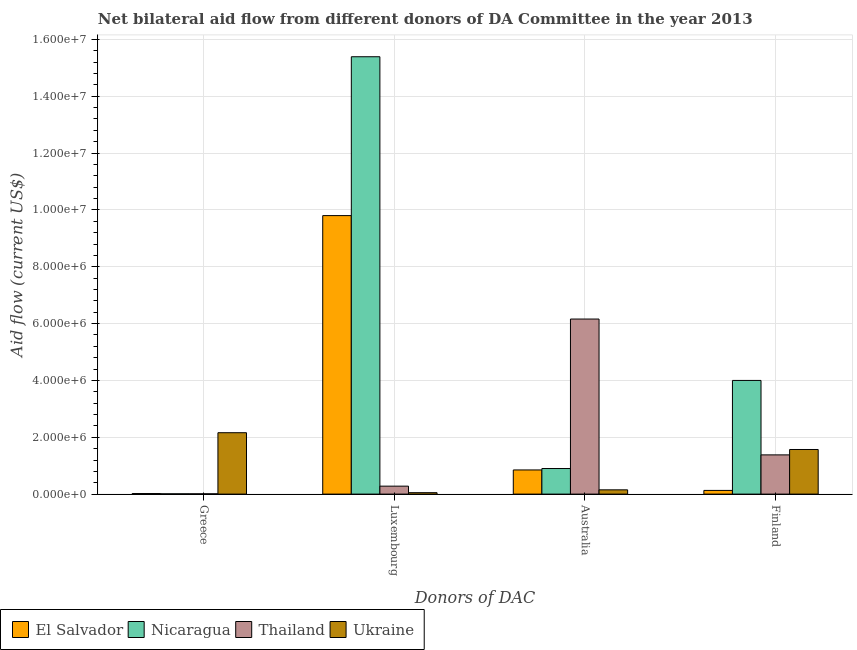How many groups of bars are there?
Your answer should be very brief. 4. How many bars are there on the 2nd tick from the left?
Ensure brevity in your answer.  4. What is the amount of aid given by finland in Thailand?
Offer a terse response. 1.38e+06. Across all countries, what is the maximum amount of aid given by greece?
Provide a succinct answer. 2.16e+06. Across all countries, what is the minimum amount of aid given by finland?
Keep it short and to the point. 1.30e+05. In which country was the amount of aid given by australia maximum?
Your answer should be compact. Thailand. In which country was the amount of aid given by australia minimum?
Ensure brevity in your answer.  Ukraine. What is the total amount of aid given by finland in the graph?
Provide a succinct answer. 7.08e+06. What is the difference between the amount of aid given by luxembourg in Thailand and that in Nicaragua?
Provide a short and direct response. -1.51e+07. What is the difference between the amount of aid given by luxembourg in Thailand and the amount of aid given by greece in El Salvador?
Offer a terse response. 2.60e+05. What is the average amount of aid given by finland per country?
Your answer should be compact. 1.77e+06. What is the difference between the amount of aid given by finland and amount of aid given by luxembourg in Nicaragua?
Offer a very short reply. -1.14e+07. What is the ratio of the amount of aid given by luxembourg in Nicaragua to that in Ukraine?
Offer a very short reply. 307.8. Is the difference between the amount of aid given by greece in Nicaragua and Thailand greater than the difference between the amount of aid given by luxembourg in Nicaragua and Thailand?
Offer a terse response. No. What is the difference between the highest and the second highest amount of aid given by greece?
Provide a short and direct response. 2.14e+06. What is the difference between the highest and the lowest amount of aid given by greece?
Your answer should be very brief. 2.15e+06. In how many countries, is the amount of aid given by australia greater than the average amount of aid given by australia taken over all countries?
Offer a terse response. 1. Is it the case that in every country, the sum of the amount of aid given by greece and amount of aid given by luxembourg is greater than the sum of amount of aid given by finland and amount of aid given by australia?
Offer a terse response. No. What does the 4th bar from the left in Greece represents?
Your response must be concise. Ukraine. What does the 3rd bar from the right in Luxembourg represents?
Offer a terse response. Nicaragua. Is it the case that in every country, the sum of the amount of aid given by greece and amount of aid given by luxembourg is greater than the amount of aid given by australia?
Ensure brevity in your answer.  No. How many bars are there?
Make the answer very short. 16. Are all the bars in the graph horizontal?
Ensure brevity in your answer.  No. What is the difference between two consecutive major ticks on the Y-axis?
Keep it short and to the point. 2.00e+06. Are the values on the major ticks of Y-axis written in scientific E-notation?
Ensure brevity in your answer.  Yes. Does the graph contain any zero values?
Make the answer very short. No. Does the graph contain grids?
Ensure brevity in your answer.  Yes. How many legend labels are there?
Your response must be concise. 4. What is the title of the graph?
Ensure brevity in your answer.  Net bilateral aid flow from different donors of DA Committee in the year 2013. What is the label or title of the X-axis?
Offer a very short reply. Donors of DAC. What is the Aid flow (current US$) of El Salvador in Greece?
Your response must be concise. 2.00e+04. What is the Aid flow (current US$) in Nicaragua in Greece?
Provide a short and direct response. 10000. What is the Aid flow (current US$) in Thailand in Greece?
Give a very brief answer. 10000. What is the Aid flow (current US$) in Ukraine in Greece?
Provide a succinct answer. 2.16e+06. What is the Aid flow (current US$) in El Salvador in Luxembourg?
Offer a very short reply. 9.80e+06. What is the Aid flow (current US$) of Nicaragua in Luxembourg?
Give a very brief answer. 1.54e+07. What is the Aid flow (current US$) of Thailand in Luxembourg?
Offer a terse response. 2.80e+05. What is the Aid flow (current US$) in El Salvador in Australia?
Your response must be concise. 8.50e+05. What is the Aid flow (current US$) of Nicaragua in Australia?
Give a very brief answer. 9.00e+05. What is the Aid flow (current US$) of Thailand in Australia?
Ensure brevity in your answer.  6.16e+06. What is the Aid flow (current US$) in Ukraine in Australia?
Make the answer very short. 1.50e+05. What is the Aid flow (current US$) in Thailand in Finland?
Your answer should be compact. 1.38e+06. What is the Aid flow (current US$) of Ukraine in Finland?
Offer a very short reply. 1.57e+06. Across all Donors of DAC, what is the maximum Aid flow (current US$) in El Salvador?
Your answer should be compact. 9.80e+06. Across all Donors of DAC, what is the maximum Aid flow (current US$) of Nicaragua?
Ensure brevity in your answer.  1.54e+07. Across all Donors of DAC, what is the maximum Aid flow (current US$) of Thailand?
Keep it short and to the point. 6.16e+06. Across all Donors of DAC, what is the maximum Aid flow (current US$) in Ukraine?
Ensure brevity in your answer.  2.16e+06. Across all Donors of DAC, what is the minimum Aid flow (current US$) in Nicaragua?
Offer a very short reply. 10000. Across all Donors of DAC, what is the minimum Aid flow (current US$) of Ukraine?
Your answer should be very brief. 5.00e+04. What is the total Aid flow (current US$) in El Salvador in the graph?
Ensure brevity in your answer.  1.08e+07. What is the total Aid flow (current US$) in Nicaragua in the graph?
Your answer should be compact. 2.03e+07. What is the total Aid flow (current US$) of Thailand in the graph?
Offer a very short reply. 7.83e+06. What is the total Aid flow (current US$) of Ukraine in the graph?
Offer a terse response. 3.93e+06. What is the difference between the Aid flow (current US$) of El Salvador in Greece and that in Luxembourg?
Your response must be concise. -9.78e+06. What is the difference between the Aid flow (current US$) of Nicaragua in Greece and that in Luxembourg?
Provide a short and direct response. -1.54e+07. What is the difference between the Aid flow (current US$) of Ukraine in Greece and that in Luxembourg?
Give a very brief answer. 2.11e+06. What is the difference between the Aid flow (current US$) in El Salvador in Greece and that in Australia?
Make the answer very short. -8.30e+05. What is the difference between the Aid flow (current US$) in Nicaragua in Greece and that in Australia?
Offer a terse response. -8.90e+05. What is the difference between the Aid flow (current US$) of Thailand in Greece and that in Australia?
Give a very brief answer. -6.15e+06. What is the difference between the Aid flow (current US$) in Ukraine in Greece and that in Australia?
Give a very brief answer. 2.01e+06. What is the difference between the Aid flow (current US$) in Nicaragua in Greece and that in Finland?
Provide a short and direct response. -3.99e+06. What is the difference between the Aid flow (current US$) of Thailand in Greece and that in Finland?
Give a very brief answer. -1.37e+06. What is the difference between the Aid flow (current US$) of Ukraine in Greece and that in Finland?
Keep it short and to the point. 5.90e+05. What is the difference between the Aid flow (current US$) in El Salvador in Luxembourg and that in Australia?
Give a very brief answer. 8.95e+06. What is the difference between the Aid flow (current US$) in Nicaragua in Luxembourg and that in Australia?
Offer a very short reply. 1.45e+07. What is the difference between the Aid flow (current US$) in Thailand in Luxembourg and that in Australia?
Your response must be concise. -5.88e+06. What is the difference between the Aid flow (current US$) in Ukraine in Luxembourg and that in Australia?
Keep it short and to the point. -1.00e+05. What is the difference between the Aid flow (current US$) of El Salvador in Luxembourg and that in Finland?
Keep it short and to the point. 9.67e+06. What is the difference between the Aid flow (current US$) of Nicaragua in Luxembourg and that in Finland?
Ensure brevity in your answer.  1.14e+07. What is the difference between the Aid flow (current US$) of Thailand in Luxembourg and that in Finland?
Your answer should be very brief. -1.10e+06. What is the difference between the Aid flow (current US$) in Ukraine in Luxembourg and that in Finland?
Your answer should be compact. -1.52e+06. What is the difference between the Aid flow (current US$) in El Salvador in Australia and that in Finland?
Your response must be concise. 7.20e+05. What is the difference between the Aid flow (current US$) of Nicaragua in Australia and that in Finland?
Ensure brevity in your answer.  -3.10e+06. What is the difference between the Aid flow (current US$) in Thailand in Australia and that in Finland?
Ensure brevity in your answer.  4.78e+06. What is the difference between the Aid flow (current US$) in Ukraine in Australia and that in Finland?
Offer a terse response. -1.42e+06. What is the difference between the Aid flow (current US$) of El Salvador in Greece and the Aid flow (current US$) of Nicaragua in Luxembourg?
Make the answer very short. -1.54e+07. What is the difference between the Aid flow (current US$) of El Salvador in Greece and the Aid flow (current US$) of Thailand in Luxembourg?
Provide a succinct answer. -2.60e+05. What is the difference between the Aid flow (current US$) of El Salvador in Greece and the Aid flow (current US$) of Ukraine in Luxembourg?
Your response must be concise. -3.00e+04. What is the difference between the Aid flow (current US$) in Nicaragua in Greece and the Aid flow (current US$) in Ukraine in Luxembourg?
Keep it short and to the point. -4.00e+04. What is the difference between the Aid flow (current US$) in Thailand in Greece and the Aid flow (current US$) in Ukraine in Luxembourg?
Ensure brevity in your answer.  -4.00e+04. What is the difference between the Aid flow (current US$) in El Salvador in Greece and the Aid flow (current US$) in Nicaragua in Australia?
Offer a terse response. -8.80e+05. What is the difference between the Aid flow (current US$) of El Salvador in Greece and the Aid flow (current US$) of Thailand in Australia?
Offer a terse response. -6.14e+06. What is the difference between the Aid flow (current US$) of El Salvador in Greece and the Aid flow (current US$) of Ukraine in Australia?
Offer a very short reply. -1.30e+05. What is the difference between the Aid flow (current US$) in Nicaragua in Greece and the Aid flow (current US$) in Thailand in Australia?
Offer a very short reply. -6.15e+06. What is the difference between the Aid flow (current US$) in Nicaragua in Greece and the Aid flow (current US$) in Ukraine in Australia?
Your response must be concise. -1.40e+05. What is the difference between the Aid flow (current US$) of El Salvador in Greece and the Aid flow (current US$) of Nicaragua in Finland?
Your answer should be very brief. -3.98e+06. What is the difference between the Aid flow (current US$) of El Salvador in Greece and the Aid flow (current US$) of Thailand in Finland?
Offer a terse response. -1.36e+06. What is the difference between the Aid flow (current US$) in El Salvador in Greece and the Aid flow (current US$) in Ukraine in Finland?
Keep it short and to the point. -1.55e+06. What is the difference between the Aid flow (current US$) of Nicaragua in Greece and the Aid flow (current US$) of Thailand in Finland?
Give a very brief answer. -1.37e+06. What is the difference between the Aid flow (current US$) of Nicaragua in Greece and the Aid flow (current US$) of Ukraine in Finland?
Offer a terse response. -1.56e+06. What is the difference between the Aid flow (current US$) of Thailand in Greece and the Aid flow (current US$) of Ukraine in Finland?
Provide a succinct answer. -1.56e+06. What is the difference between the Aid flow (current US$) in El Salvador in Luxembourg and the Aid flow (current US$) in Nicaragua in Australia?
Your answer should be very brief. 8.90e+06. What is the difference between the Aid flow (current US$) of El Salvador in Luxembourg and the Aid flow (current US$) of Thailand in Australia?
Your answer should be compact. 3.64e+06. What is the difference between the Aid flow (current US$) in El Salvador in Luxembourg and the Aid flow (current US$) in Ukraine in Australia?
Offer a very short reply. 9.65e+06. What is the difference between the Aid flow (current US$) of Nicaragua in Luxembourg and the Aid flow (current US$) of Thailand in Australia?
Provide a short and direct response. 9.23e+06. What is the difference between the Aid flow (current US$) of Nicaragua in Luxembourg and the Aid flow (current US$) of Ukraine in Australia?
Provide a short and direct response. 1.52e+07. What is the difference between the Aid flow (current US$) of Thailand in Luxembourg and the Aid flow (current US$) of Ukraine in Australia?
Offer a very short reply. 1.30e+05. What is the difference between the Aid flow (current US$) of El Salvador in Luxembourg and the Aid flow (current US$) of Nicaragua in Finland?
Your answer should be very brief. 5.80e+06. What is the difference between the Aid flow (current US$) in El Salvador in Luxembourg and the Aid flow (current US$) in Thailand in Finland?
Make the answer very short. 8.42e+06. What is the difference between the Aid flow (current US$) of El Salvador in Luxembourg and the Aid flow (current US$) of Ukraine in Finland?
Your answer should be very brief. 8.23e+06. What is the difference between the Aid flow (current US$) of Nicaragua in Luxembourg and the Aid flow (current US$) of Thailand in Finland?
Offer a terse response. 1.40e+07. What is the difference between the Aid flow (current US$) of Nicaragua in Luxembourg and the Aid flow (current US$) of Ukraine in Finland?
Give a very brief answer. 1.38e+07. What is the difference between the Aid flow (current US$) in Thailand in Luxembourg and the Aid flow (current US$) in Ukraine in Finland?
Provide a short and direct response. -1.29e+06. What is the difference between the Aid flow (current US$) of El Salvador in Australia and the Aid flow (current US$) of Nicaragua in Finland?
Give a very brief answer. -3.15e+06. What is the difference between the Aid flow (current US$) of El Salvador in Australia and the Aid flow (current US$) of Thailand in Finland?
Give a very brief answer. -5.30e+05. What is the difference between the Aid flow (current US$) of El Salvador in Australia and the Aid flow (current US$) of Ukraine in Finland?
Offer a very short reply. -7.20e+05. What is the difference between the Aid flow (current US$) in Nicaragua in Australia and the Aid flow (current US$) in Thailand in Finland?
Offer a terse response. -4.80e+05. What is the difference between the Aid flow (current US$) of Nicaragua in Australia and the Aid flow (current US$) of Ukraine in Finland?
Provide a succinct answer. -6.70e+05. What is the difference between the Aid flow (current US$) of Thailand in Australia and the Aid flow (current US$) of Ukraine in Finland?
Your answer should be compact. 4.59e+06. What is the average Aid flow (current US$) of El Salvador per Donors of DAC?
Provide a succinct answer. 2.70e+06. What is the average Aid flow (current US$) in Nicaragua per Donors of DAC?
Give a very brief answer. 5.08e+06. What is the average Aid flow (current US$) in Thailand per Donors of DAC?
Make the answer very short. 1.96e+06. What is the average Aid flow (current US$) of Ukraine per Donors of DAC?
Offer a very short reply. 9.82e+05. What is the difference between the Aid flow (current US$) of El Salvador and Aid flow (current US$) of Ukraine in Greece?
Your response must be concise. -2.14e+06. What is the difference between the Aid flow (current US$) of Nicaragua and Aid flow (current US$) of Thailand in Greece?
Give a very brief answer. 0. What is the difference between the Aid flow (current US$) in Nicaragua and Aid flow (current US$) in Ukraine in Greece?
Your response must be concise. -2.15e+06. What is the difference between the Aid flow (current US$) in Thailand and Aid flow (current US$) in Ukraine in Greece?
Give a very brief answer. -2.15e+06. What is the difference between the Aid flow (current US$) of El Salvador and Aid flow (current US$) of Nicaragua in Luxembourg?
Ensure brevity in your answer.  -5.59e+06. What is the difference between the Aid flow (current US$) in El Salvador and Aid flow (current US$) in Thailand in Luxembourg?
Offer a terse response. 9.52e+06. What is the difference between the Aid flow (current US$) of El Salvador and Aid flow (current US$) of Ukraine in Luxembourg?
Provide a succinct answer. 9.75e+06. What is the difference between the Aid flow (current US$) of Nicaragua and Aid flow (current US$) of Thailand in Luxembourg?
Provide a succinct answer. 1.51e+07. What is the difference between the Aid flow (current US$) in Nicaragua and Aid flow (current US$) in Ukraine in Luxembourg?
Make the answer very short. 1.53e+07. What is the difference between the Aid flow (current US$) in Thailand and Aid flow (current US$) in Ukraine in Luxembourg?
Provide a short and direct response. 2.30e+05. What is the difference between the Aid flow (current US$) in El Salvador and Aid flow (current US$) in Thailand in Australia?
Keep it short and to the point. -5.31e+06. What is the difference between the Aid flow (current US$) in Nicaragua and Aid flow (current US$) in Thailand in Australia?
Your answer should be very brief. -5.26e+06. What is the difference between the Aid flow (current US$) in Nicaragua and Aid flow (current US$) in Ukraine in Australia?
Make the answer very short. 7.50e+05. What is the difference between the Aid flow (current US$) of Thailand and Aid flow (current US$) of Ukraine in Australia?
Your response must be concise. 6.01e+06. What is the difference between the Aid flow (current US$) of El Salvador and Aid flow (current US$) of Nicaragua in Finland?
Make the answer very short. -3.87e+06. What is the difference between the Aid flow (current US$) of El Salvador and Aid flow (current US$) of Thailand in Finland?
Offer a terse response. -1.25e+06. What is the difference between the Aid flow (current US$) of El Salvador and Aid flow (current US$) of Ukraine in Finland?
Offer a very short reply. -1.44e+06. What is the difference between the Aid flow (current US$) of Nicaragua and Aid flow (current US$) of Thailand in Finland?
Offer a terse response. 2.62e+06. What is the difference between the Aid flow (current US$) of Nicaragua and Aid flow (current US$) of Ukraine in Finland?
Provide a short and direct response. 2.43e+06. What is the ratio of the Aid flow (current US$) of El Salvador in Greece to that in Luxembourg?
Ensure brevity in your answer.  0. What is the ratio of the Aid flow (current US$) in Nicaragua in Greece to that in Luxembourg?
Keep it short and to the point. 0. What is the ratio of the Aid flow (current US$) in Thailand in Greece to that in Luxembourg?
Provide a succinct answer. 0.04. What is the ratio of the Aid flow (current US$) of Ukraine in Greece to that in Luxembourg?
Offer a very short reply. 43.2. What is the ratio of the Aid flow (current US$) in El Salvador in Greece to that in Australia?
Keep it short and to the point. 0.02. What is the ratio of the Aid flow (current US$) in Nicaragua in Greece to that in Australia?
Your answer should be compact. 0.01. What is the ratio of the Aid flow (current US$) of Thailand in Greece to that in Australia?
Offer a terse response. 0. What is the ratio of the Aid flow (current US$) in El Salvador in Greece to that in Finland?
Provide a short and direct response. 0.15. What is the ratio of the Aid flow (current US$) of Nicaragua in Greece to that in Finland?
Ensure brevity in your answer.  0. What is the ratio of the Aid flow (current US$) of Thailand in Greece to that in Finland?
Make the answer very short. 0.01. What is the ratio of the Aid flow (current US$) of Ukraine in Greece to that in Finland?
Provide a short and direct response. 1.38. What is the ratio of the Aid flow (current US$) of El Salvador in Luxembourg to that in Australia?
Your answer should be very brief. 11.53. What is the ratio of the Aid flow (current US$) of Nicaragua in Luxembourg to that in Australia?
Make the answer very short. 17.1. What is the ratio of the Aid flow (current US$) of Thailand in Luxembourg to that in Australia?
Your answer should be very brief. 0.05. What is the ratio of the Aid flow (current US$) of Ukraine in Luxembourg to that in Australia?
Make the answer very short. 0.33. What is the ratio of the Aid flow (current US$) in El Salvador in Luxembourg to that in Finland?
Your answer should be compact. 75.38. What is the ratio of the Aid flow (current US$) in Nicaragua in Luxembourg to that in Finland?
Provide a succinct answer. 3.85. What is the ratio of the Aid flow (current US$) in Thailand in Luxembourg to that in Finland?
Provide a succinct answer. 0.2. What is the ratio of the Aid flow (current US$) of Ukraine in Luxembourg to that in Finland?
Make the answer very short. 0.03. What is the ratio of the Aid flow (current US$) of El Salvador in Australia to that in Finland?
Offer a terse response. 6.54. What is the ratio of the Aid flow (current US$) in Nicaragua in Australia to that in Finland?
Your answer should be compact. 0.23. What is the ratio of the Aid flow (current US$) of Thailand in Australia to that in Finland?
Ensure brevity in your answer.  4.46. What is the ratio of the Aid flow (current US$) in Ukraine in Australia to that in Finland?
Offer a terse response. 0.1. What is the difference between the highest and the second highest Aid flow (current US$) of El Salvador?
Provide a short and direct response. 8.95e+06. What is the difference between the highest and the second highest Aid flow (current US$) of Nicaragua?
Ensure brevity in your answer.  1.14e+07. What is the difference between the highest and the second highest Aid flow (current US$) of Thailand?
Ensure brevity in your answer.  4.78e+06. What is the difference between the highest and the second highest Aid flow (current US$) in Ukraine?
Provide a succinct answer. 5.90e+05. What is the difference between the highest and the lowest Aid flow (current US$) in El Salvador?
Make the answer very short. 9.78e+06. What is the difference between the highest and the lowest Aid flow (current US$) in Nicaragua?
Your answer should be very brief. 1.54e+07. What is the difference between the highest and the lowest Aid flow (current US$) in Thailand?
Ensure brevity in your answer.  6.15e+06. What is the difference between the highest and the lowest Aid flow (current US$) in Ukraine?
Provide a short and direct response. 2.11e+06. 